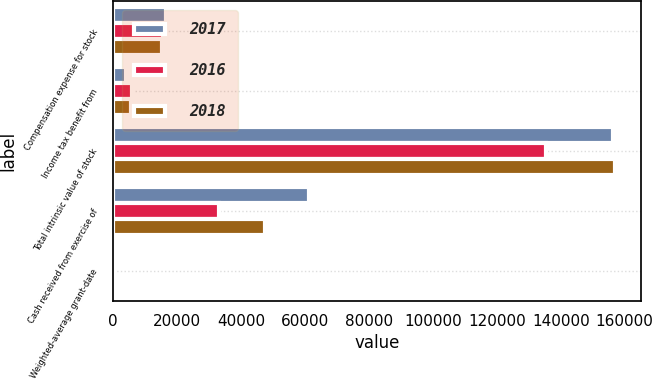<chart> <loc_0><loc_0><loc_500><loc_500><stacked_bar_chart><ecel><fcel>Compensation expense for stock<fcel>Income tax benefit from<fcel>Total intrinsic value of stock<fcel>Cash received from exercise of<fcel>Weighted-average grant-date<nl><fcel>2017<fcel>16521<fcel>4093<fcel>156327<fcel>61403<fcel>76.57<nl><fcel>2016<fcel>15561<fcel>5934<fcel>135533<fcel>33229<fcel>62.79<nl><fcel>2018<fcel>15404<fcel>5753<fcel>157115<fcel>47394<fcel>63.42<nl></chart> 